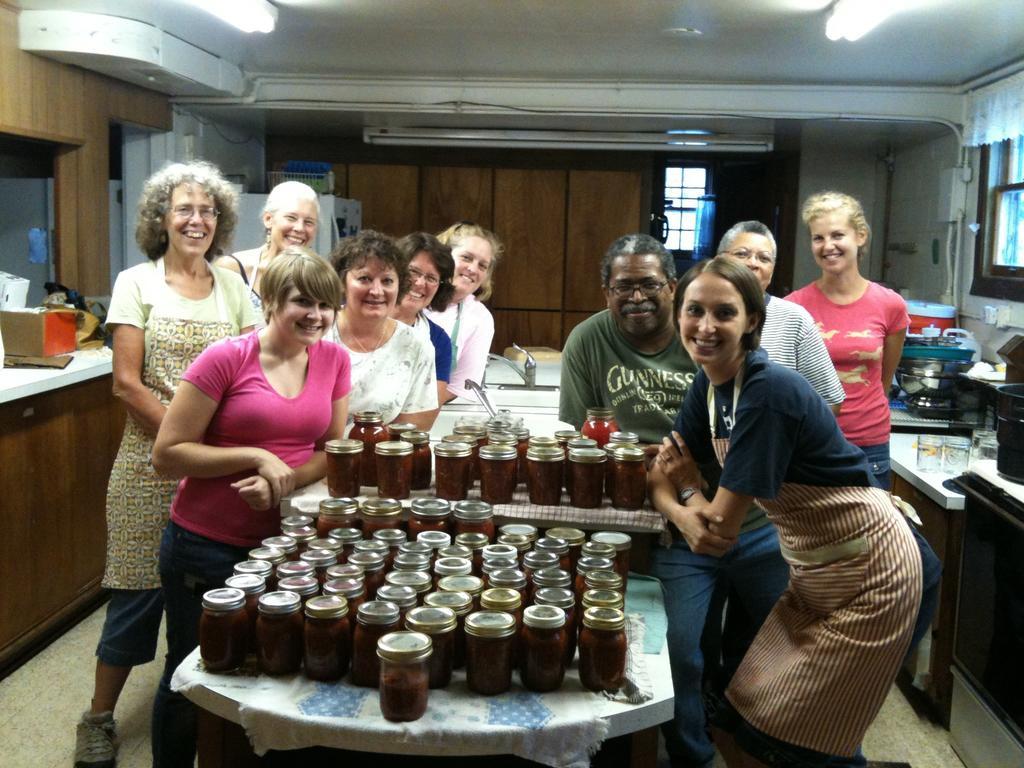In one or two sentences, can you explain what this image depicts? This picture is inside view of a room. In the center of the image group of people are standing. A table is present in the center of the image. On table we can see bottles are present. In the background of the image we can see cupboards, light, wall, container, boxes are present. At the bottom of the image floor is there. In the middle of the image tap and sink are present. 